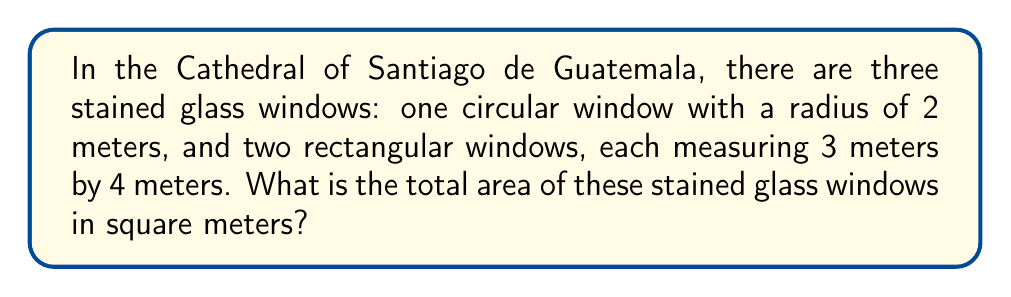Solve this math problem. Let's calculate the area of each window and then sum them up:

1. Circular window:
   The area of a circle is given by the formula $A = \pi r^2$
   $A = \pi \cdot 2^2 = 4\pi$ square meters

2. Rectangular windows:
   The area of a rectangle is given by the formula $A = l \cdot w$
   For each rectangular window: $A = 3 \cdot 4 = 12$ square meters
   There are two rectangular windows, so the total area is $2 \cdot 12 = 24$ square meters

3. Total area:
   Sum the areas of all windows:
   $\text{Total Area} = 4\pi + 24$ square meters

4. Simplify:
   $4\pi \approx 12.57$ (rounded to two decimal places)
   $12.57 + 24 = 36.57$ square meters

Therefore, the total area of the stained glass windows is approximately 36.57 square meters.
Answer: $4\pi + 24 \approx 36.57$ m² 